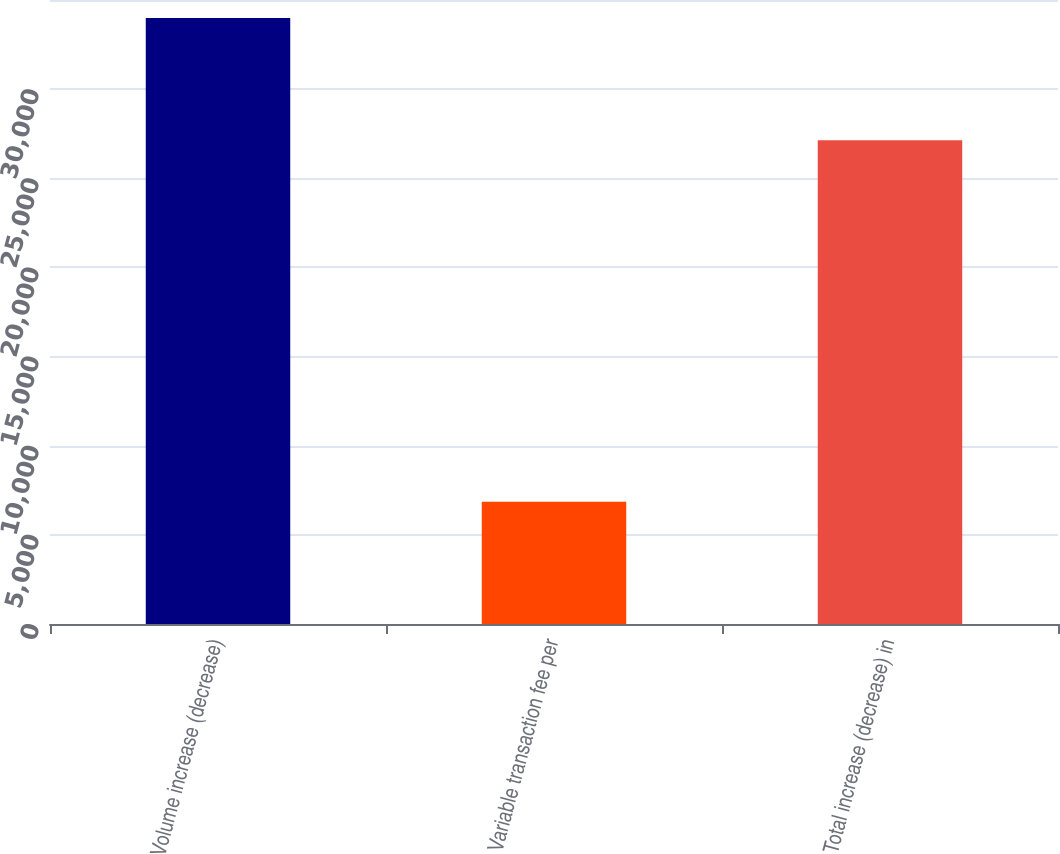Convert chart to OTSL. <chart><loc_0><loc_0><loc_500><loc_500><bar_chart><fcel>Volume increase (decrease)<fcel>Variable transaction fee per<fcel>Total increase (decrease) in<nl><fcel>33993<fcel>6853<fcel>27140<nl></chart> 